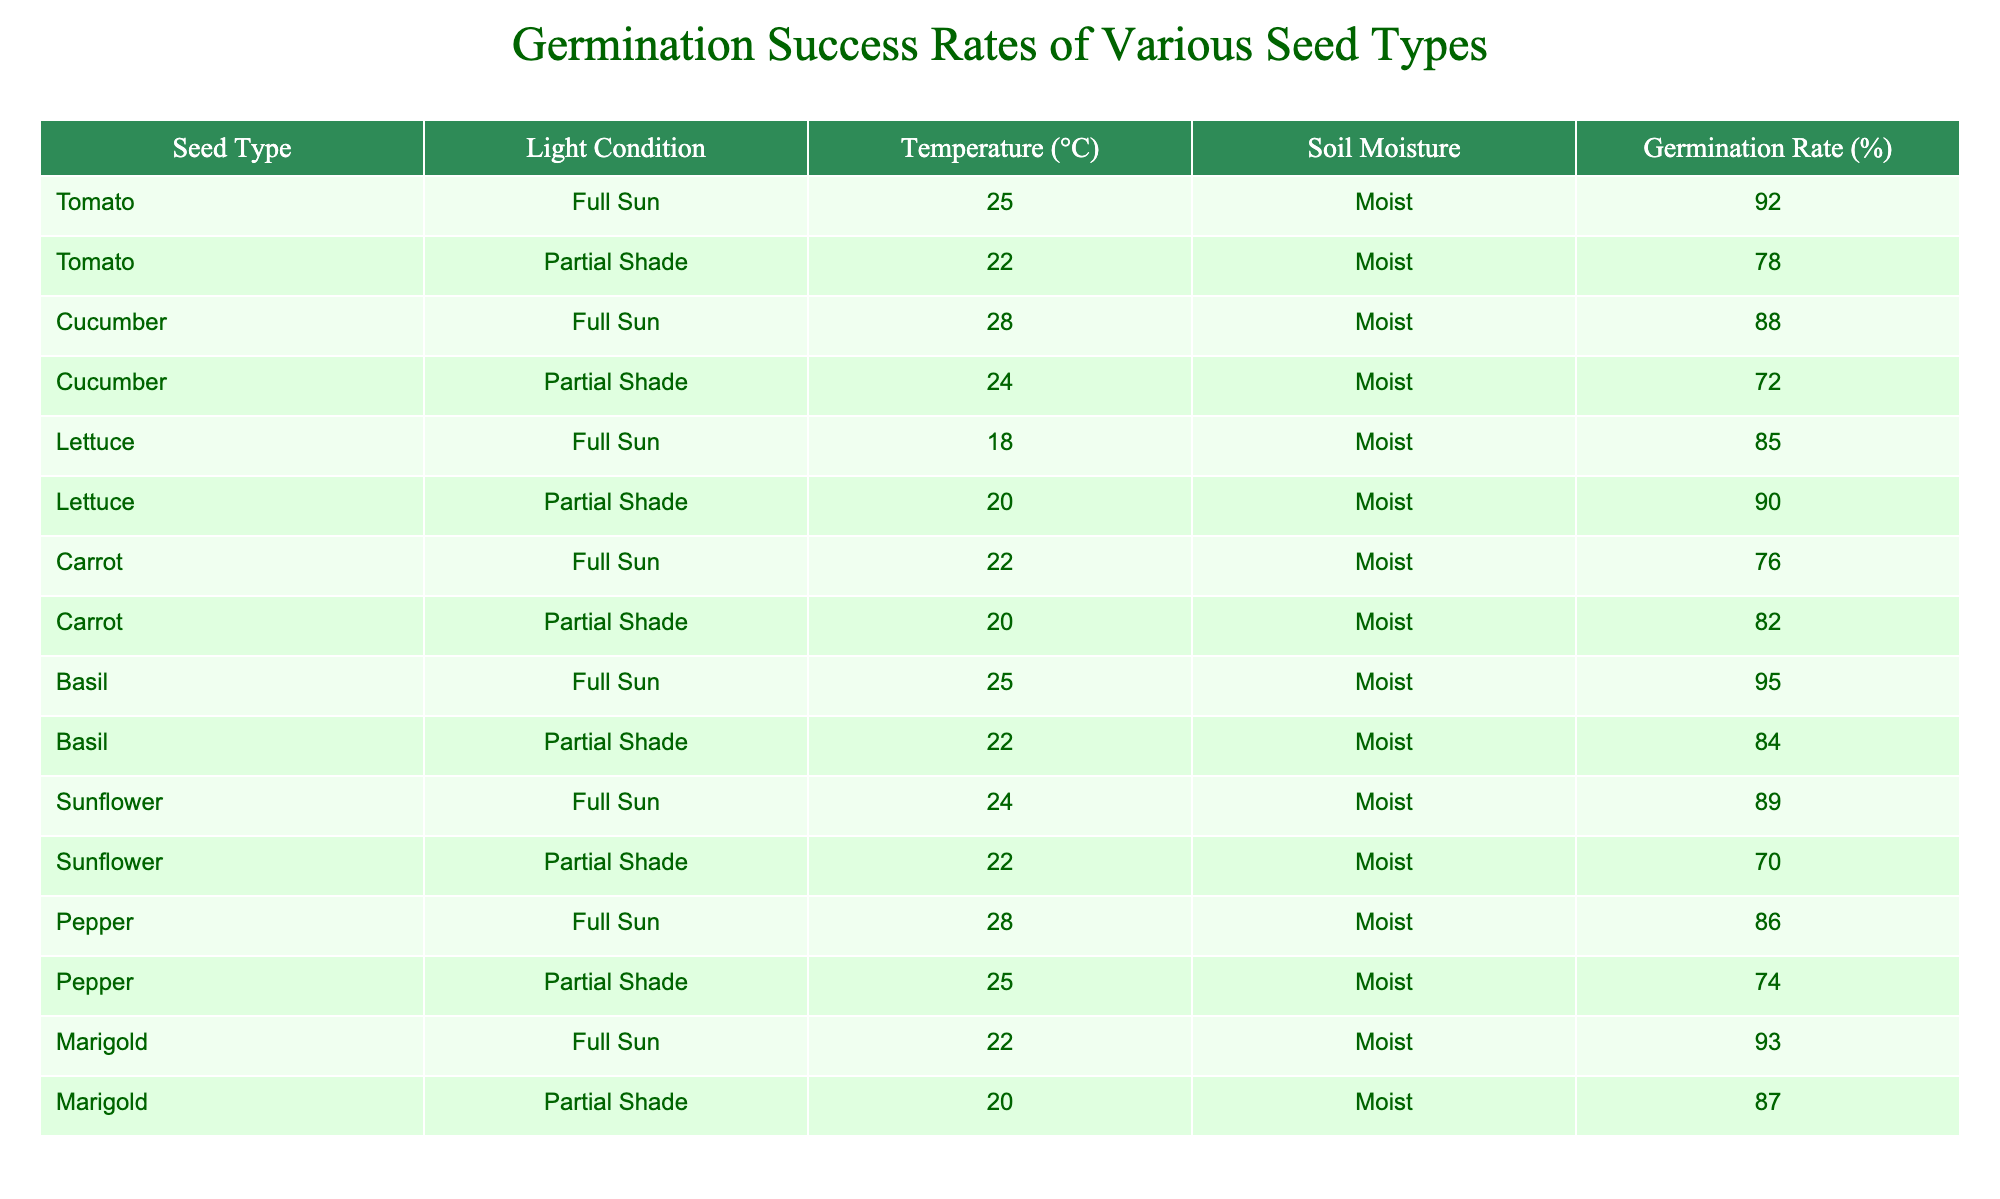What is the germination rate of Basil under Full Sun conditions? The table shows that the germination rate for Basil under Full Sun conditions is listed next to those conditions. By checking the 'Basil' row and 'Full Sun' column, the germination rate reads 95%.
Answer: 95% What is the lowest germination rate for Cucumber under any light condition? To find this, I look at the germination rates for Cucumber under both light conditions: in Full Sun it is 88% and in Partial Shade it is 72%. The lowest of these two rates is 72%.
Answer: 72% Is the germination rate for Lettuce higher in Partial Shade or Full Sun? By examining the rates, I see that Lettuce has a germination rate of 90% in Partial Shade and 85% in Full Sun. Since 90% is greater than 85%, Lettuce germinates better in Partial Shade.
Answer: Partial Shade What is the average germination rate for all seed types in Full Sun? First, I identify the germination rates for all seed types under Full Sun: Tomato (92%), Cucumber (88%), Lettuce (85%), Carrot (76%), Basil (95%), Sunflower (89%), Pepper (86%), and Marigold (93%). Adding these gives (92 + 88 + 85 + 76 + 95 + 89 + 86 + 93) = 714. There are 8 seed types, so the average is 714 / 8 = 89.25%.
Answer: 89.25% Do any seeds have the same germination rate under Partial Shade conditions? I look for rows with matching germination rates in the Partial Shade condition. Checking the rates reveals that Cucumber has 72%, Carrot has 82%, Lettuce has 90%, and Marigold has 87%. There are no matches among these rates, indicating that no seeds share the same germination rate under Partial Shade conditions.
Answer: No What is the difference in germination rates for Pepper between Full Sun and Partial Shade? According to the data, the germination rate for Pepper in Full Sun is 86%, while in Partial Shade it is 74%. The difference is calculated as 86% - 74% = 12%.
Answer: 12% Which seed type has the highest germination rate in Partial Shade? By checking the germination rates under Partial Shade, I find Basil with 84%, Tomato with 78%, Cucumber with 72%, Lettuce with 90%, Carrot with 82%, Sunflower with 70%, Pepper with 74%, and Marigold with 87%. The highest of these is 90% for Lettuce.
Answer: Lettuce What is the total germination rate for all seed types combined in Full Sun? I take all the germination rates listed for Full Sun, which are 92%, 88%, 85%, 76%, 95%, 89%, 86%, and 93%. Adding these together gives (92 + 88 + 85 + 76 + 95 + 89 + 86 + 93) = 714%. This is the total germination rate across all seed types in Full Sun.
Answer: 714% 